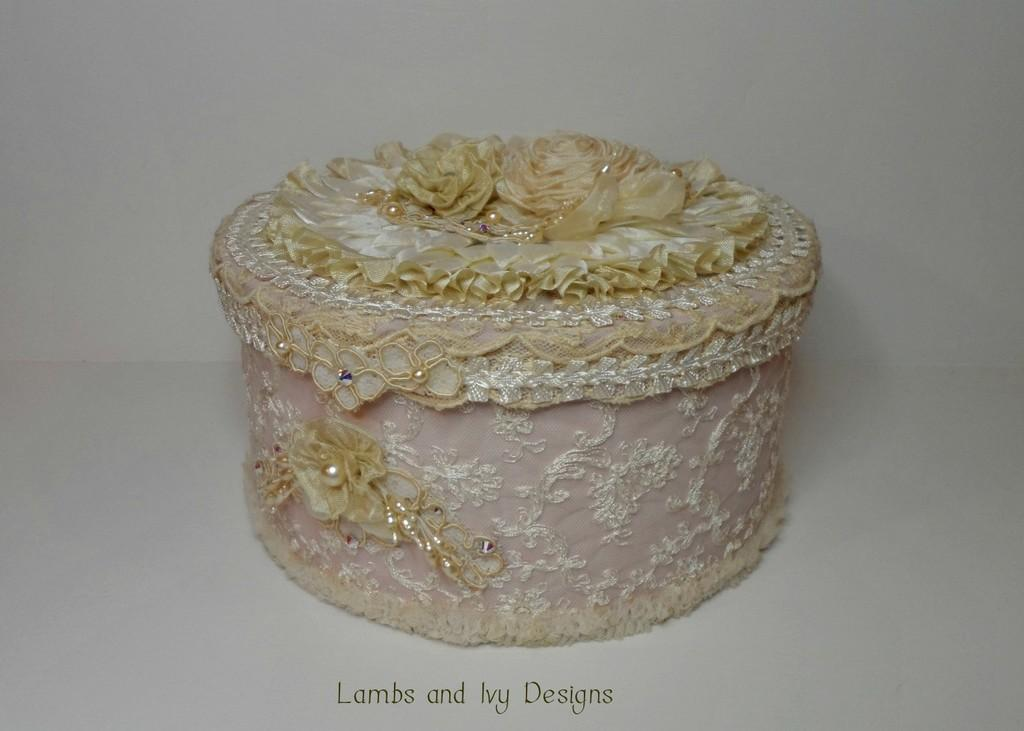What is the main object in the image? There is a designed box in the image. What color is the background of the image? The background of the image is white. What type of beam is holding up the basin in the image? There is no beam or basin present in the image; it only features a designed box and a white background. 